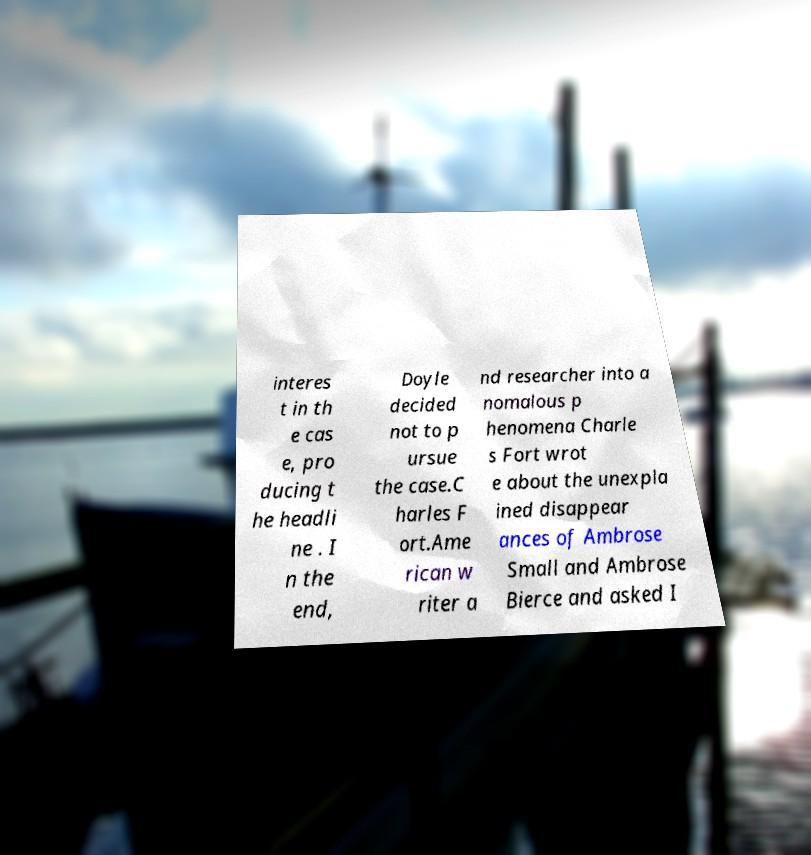I need the written content from this picture converted into text. Can you do that? interes t in th e cas e, pro ducing t he headli ne . I n the end, Doyle decided not to p ursue the case.C harles F ort.Ame rican w riter a nd researcher into a nomalous p henomena Charle s Fort wrot e about the unexpla ined disappear ances of Ambrose Small and Ambrose Bierce and asked I 